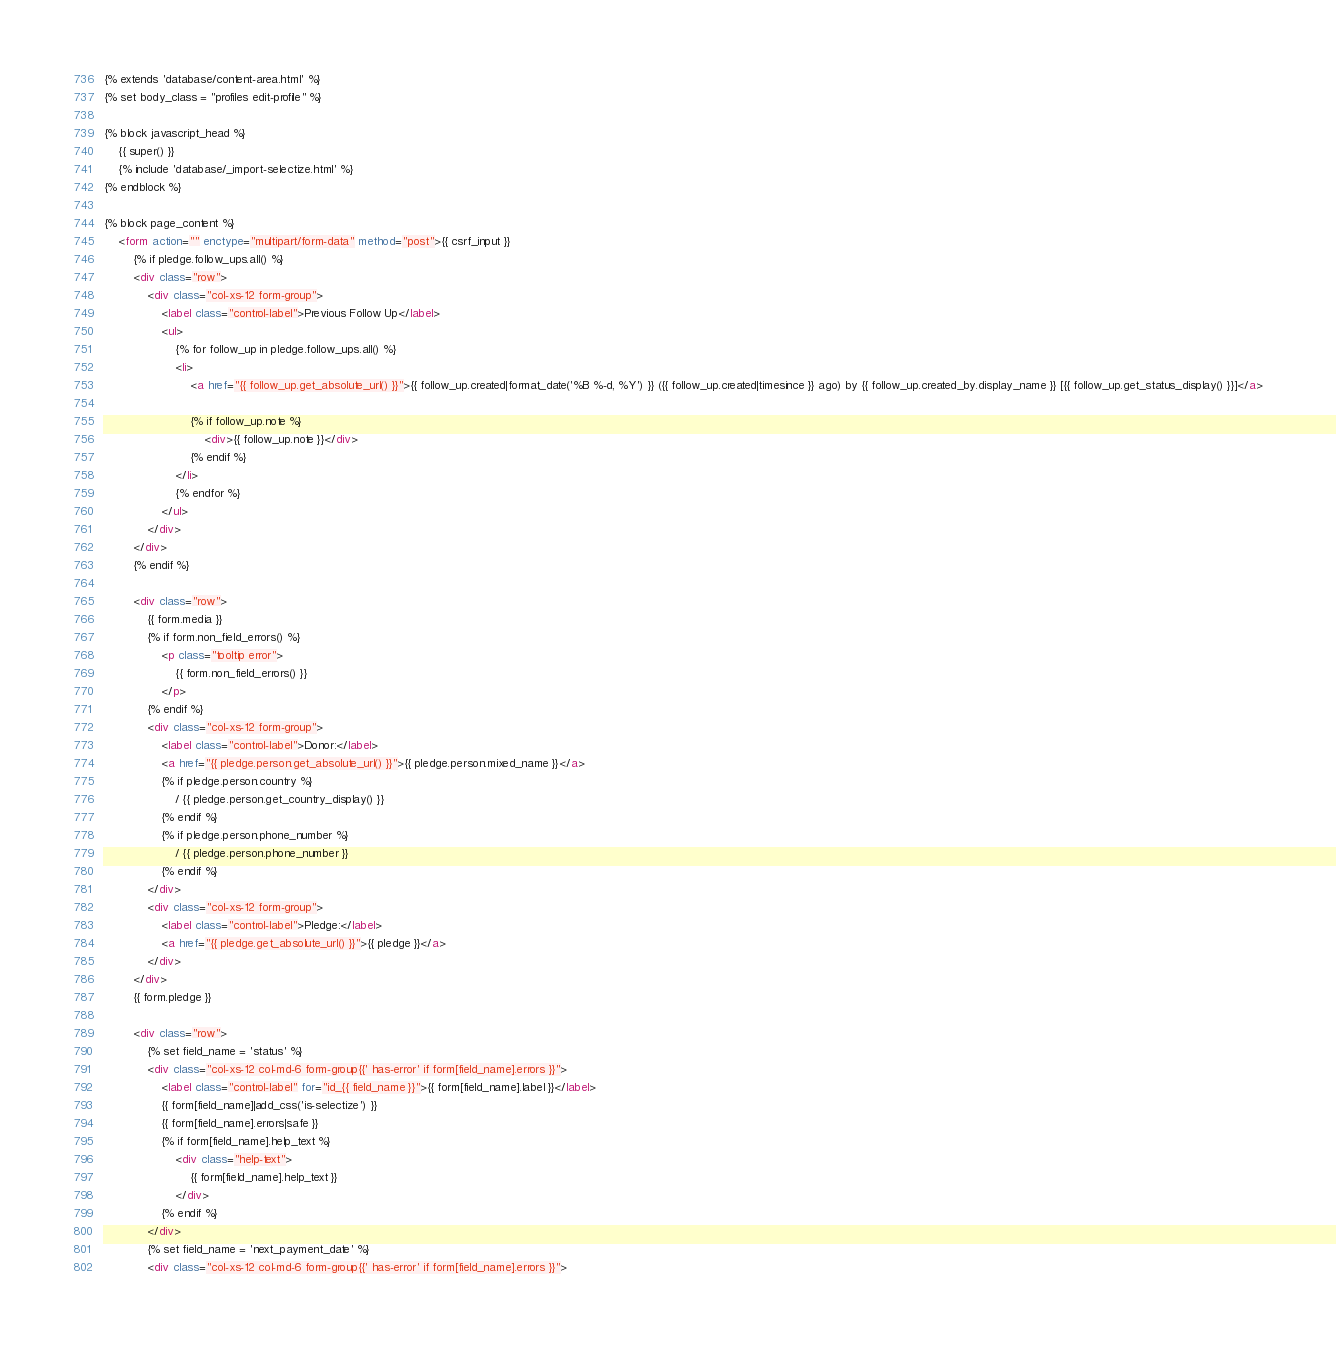<code> <loc_0><loc_0><loc_500><loc_500><_HTML_>{% extends 'database/content-area.html' %}
{% set body_class = "profiles edit-profile" %}

{% block javascript_head %}
    {{ super() }}
    {% include 'database/_import-selectize.html' %}
{% endblock %}

{% block page_content %}
    <form action="" enctype="multipart/form-data" method="post">{{ csrf_input }}
        {% if pledge.follow_ups.all() %}
        <div class="row">
            <div class="col-xs-12 form-group">
                <label class="control-label">Previous Follow Up</label>
                <ul>
                    {% for follow_up in pledge.follow_ups.all() %}
                    <li>
                        <a href="{{ follow_up.get_absolute_url() }}">{{ follow_up.created|format_date('%B %-d, %Y') }} ({{ follow_up.created|timesince }} ago) by {{ follow_up.created_by.display_name }} [{{ follow_up.get_status_display() }}]</a>

                        {% if follow_up.note %}
                            <div>{{ follow_up.note }}</div>
                        {% endif %}
                    </li>
                    {% endfor %}
                </ul>
            </div>
        </div>
        {% endif %}

        <div class="row">
            {{ form.media }}
            {% if form.non_field_errors() %}
                <p class="tooltip error">
                    {{ form.non_field_errors() }}
                </p>
            {% endif %}
            <div class="col-xs-12 form-group">
                <label class="control-label">Donor:</label>
                <a href="{{ pledge.person.get_absolute_url() }}">{{ pledge.person.mixed_name }}</a>
                {% if pledge.person.country %}
                    / {{ pledge.person.get_country_display() }}
                {% endif %}
                {% if pledge.person.phone_number %}
                    / {{ pledge.person.phone_number }}
                {% endif %}
            </div>
            <div class="col-xs-12 form-group">
                <label class="control-label">Pledge:</label>
                <a href="{{ pledge.get_absolute_url() }}">{{ pledge }}</a>
            </div>
        </div>
        {{ form.pledge }}

        <div class="row">
            {% set field_name = 'status' %}
            <div class="col-xs-12 col-md-6 form-group{{' has-error' if form[field_name].errors }}">
                <label class="control-label" for="id_{{ field_name }}">{{ form[field_name].label }}</label>
                {{ form[field_name]|add_css('is-selectize') }}
                {{ form[field_name].errors|safe }}
                {% if form[field_name].help_text %}
                    <div class="help-text">
                        {{ form[field_name].help_text }}
                    </div>
                {% endif %}
            </div>
            {% set field_name = 'next_payment_date' %}
            <div class="col-xs-12 col-md-6 form-group{{' has-error' if form[field_name].errors }}"></code> 